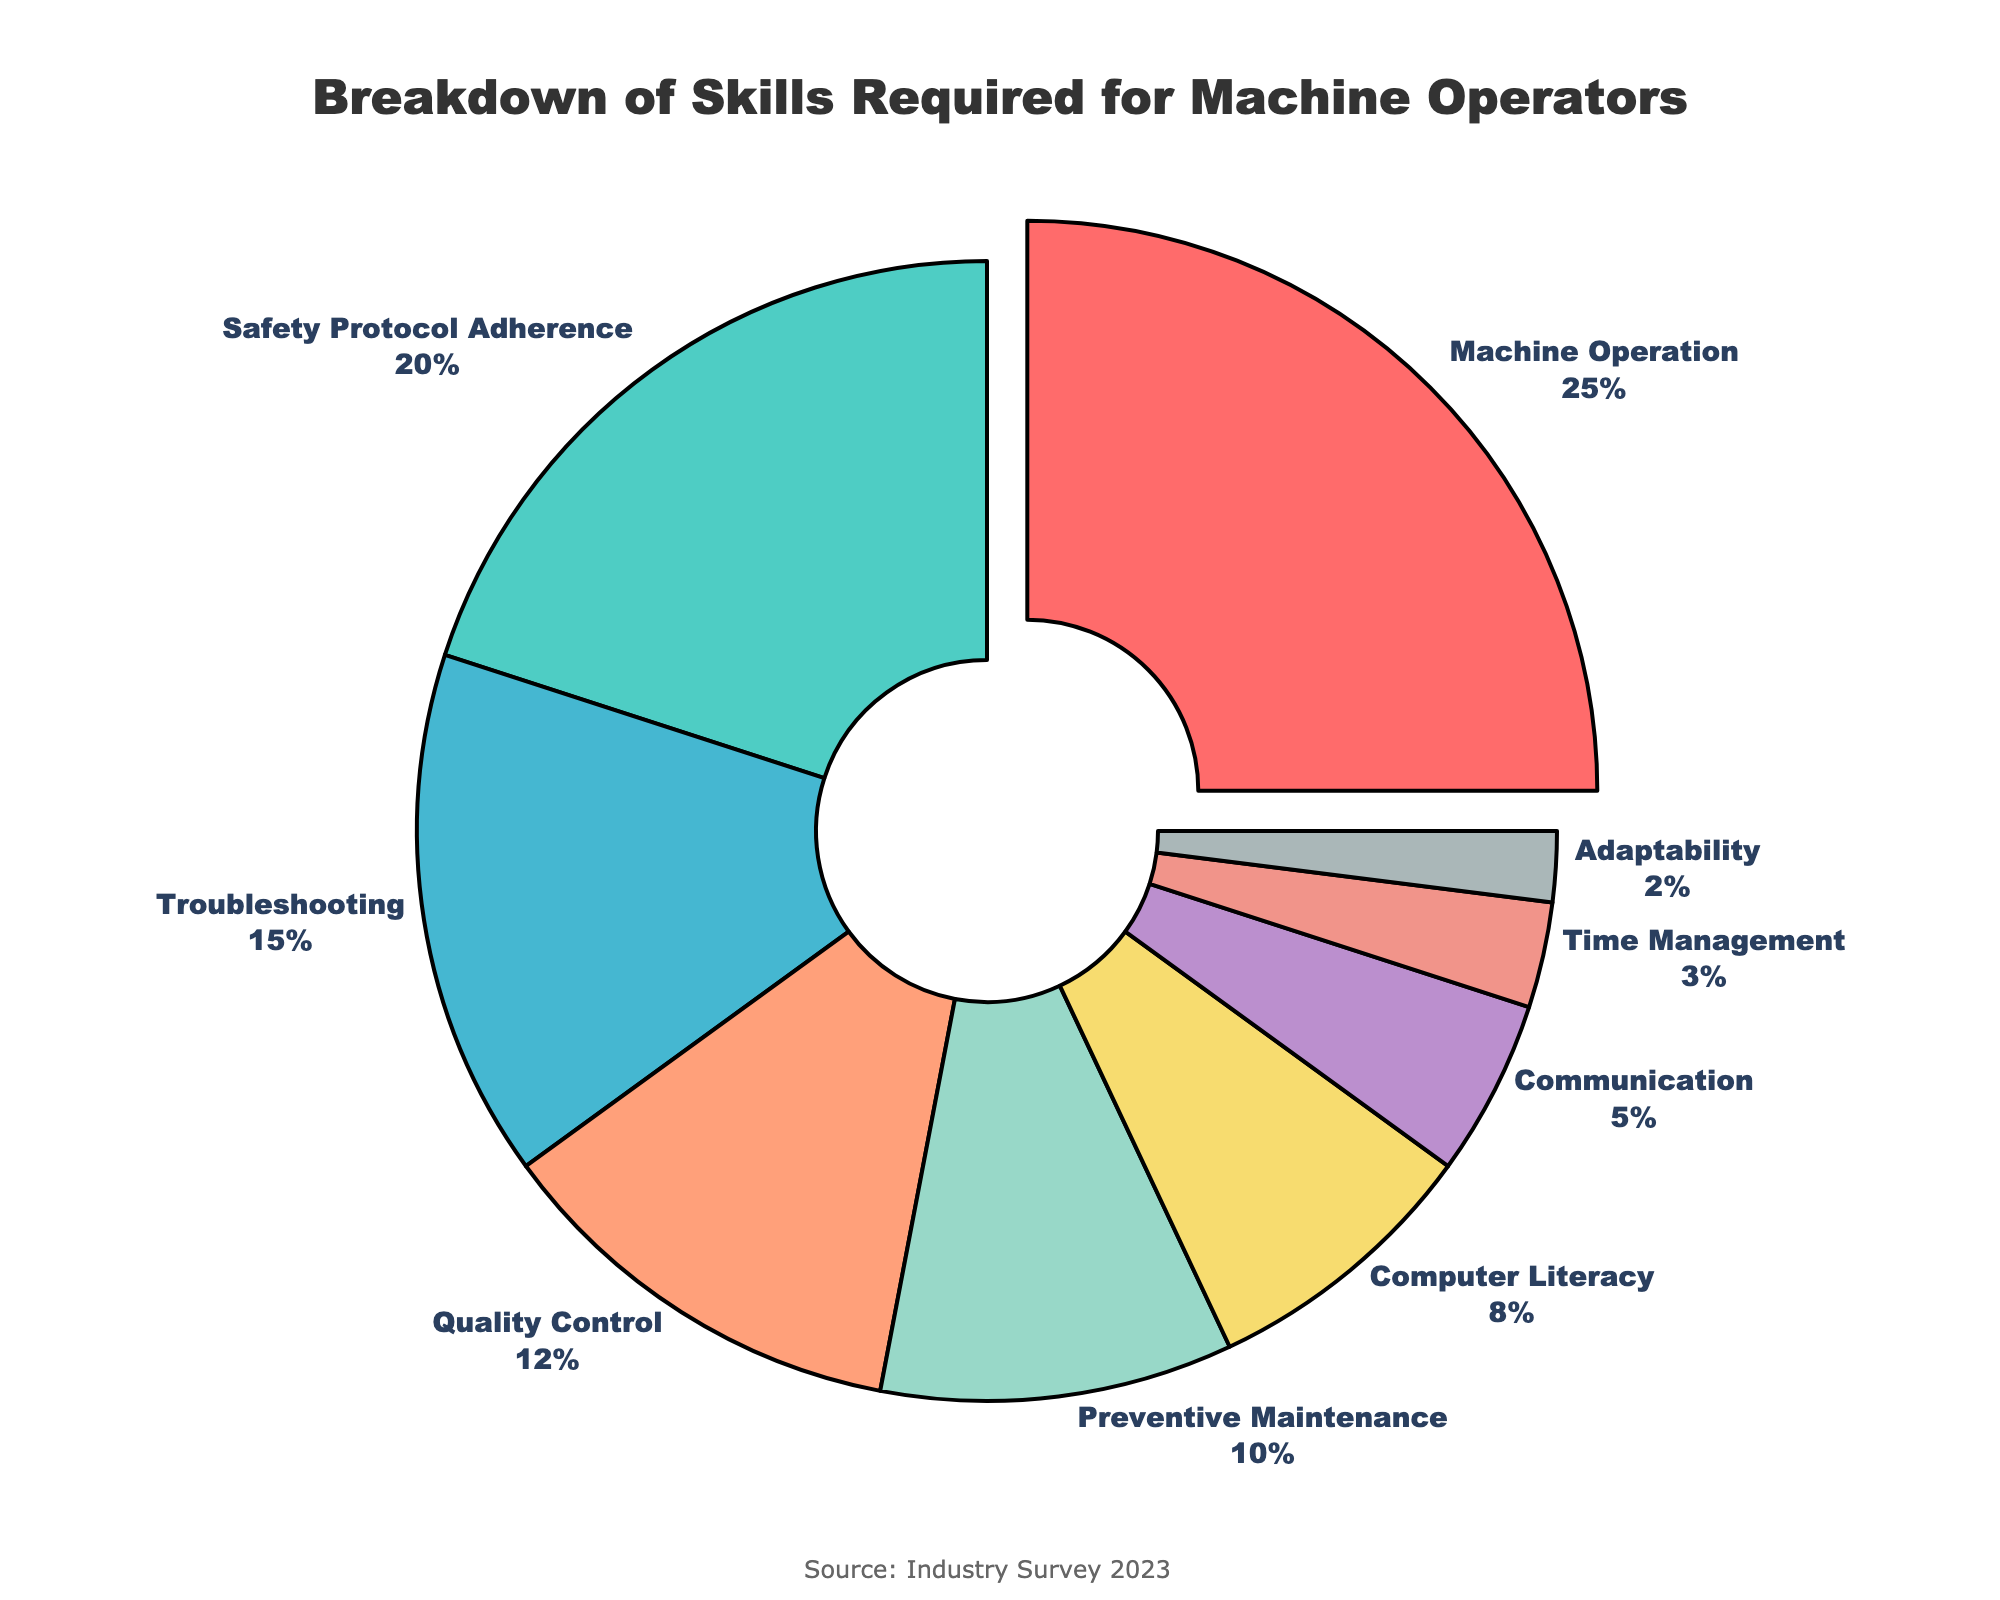What skill occupies the largest portion in the pie chart? The largest portion is marked by the section pulled out, which corresponds to Machine Operation, constituting 25%.
Answer: Machine Operation Which skill has the smallest percentage? The smallest segment in the pie chart represents Adaptability, which is labeled with 2%.
Answer: Adaptability What is the total percentage of Safety Protocol Adherence and Troubleshooting combined? Safety Protocol Adherence has 20% and Troubleshooting has 15%. Adding these together: 20% + 15% = 35%.
Answer: 35% Which skills have a percentage higher than 10% but less than 20%? By examining the labels outside the pie chart, skills within this range are Safety Protocol Adherence (20%) and Troubleshooting (15%).
Answer: Safety Protocol Adherence, Troubleshooting How many skills together constitute exactly 45% of the total percentage? Observing their percentages, Quality Control is 12% and Preventive Maintenance is 10%, together they make (12% + 10% = 22%). Adding Computer Literacy (8%) gives (22% + 8% = 30%). Including Communication (5%) (30% + 5% = 35%) and Time Management (3%) (35% + 3% = 38%). Adding Adaptability (2%): (38% + 2% = 40%). Then, Safety Protocol Adherence (20%) (40% + 20% = 60%). So, 60% exceeds 45%. However, if we consider just Safety Protocol Adherence (20%) and Troubleshooting (15%), they give exactly 35%; then adding Quality Control (12%) gives (35% + 12% = 47%), which also exceeds 45%. Hence: Preventive Maintenance, Computer Literacy, Communication, Time Management, Adaptability
Answer: 5 Are there more skills with less than 10% or more than 10%? Observing the pie chart, skills with more than 10% are Machine Operation (25%), Safety Protocol Adherence (20%), Troubleshooting (15%), and Quality Control (12%). Skills with less than 10% are Preventive Maintenance (10%), Computer Literacy (8%), Communication (5%), Time Management (3%), and Adaptability (2%). Four skills are more than 10%, and five skills are less than 10%.
Answer: Less than 10% Which skill segment is represented with a yellow color? Visually identifying the yellow color section in the pie chart and referring to the associated label, the segment corresponds to Preventive Maintenance.
Answer: Preventive Maintenance 